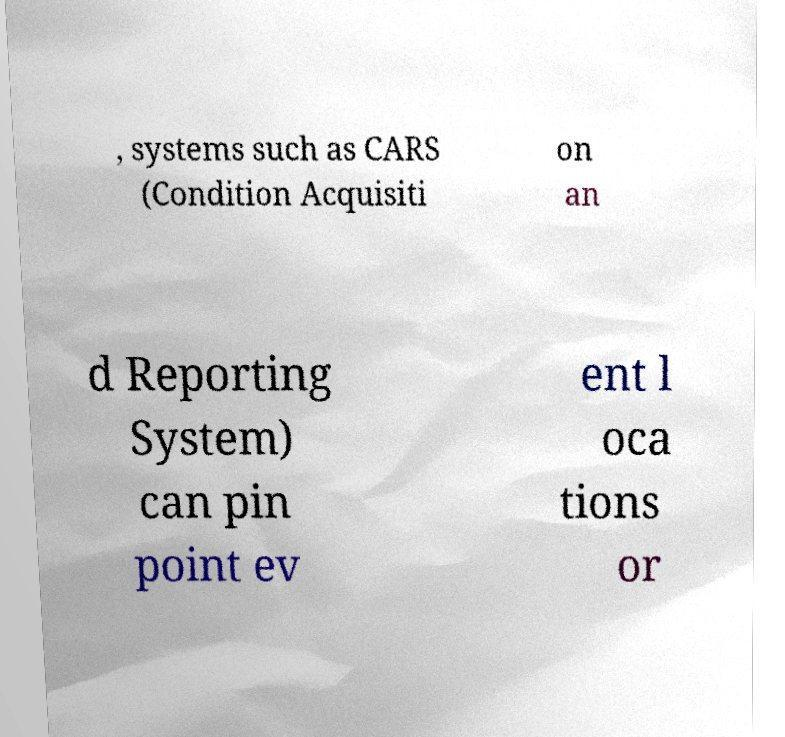Can you read and provide the text displayed in the image?This photo seems to have some interesting text. Can you extract and type it out for me? , systems such as CARS (Condition Acquisiti on an d Reporting System) can pin point ev ent l oca tions or 